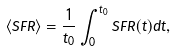Convert formula to latex. <formula><loc_0><loc_0><loc_500><loc_500>\langle S F R \rangle = \frac { 1 } { t _ { 0 } } \int _ { 0 } ^ { t _ { 0 } } S F R ( t ) d t ,</formula> 